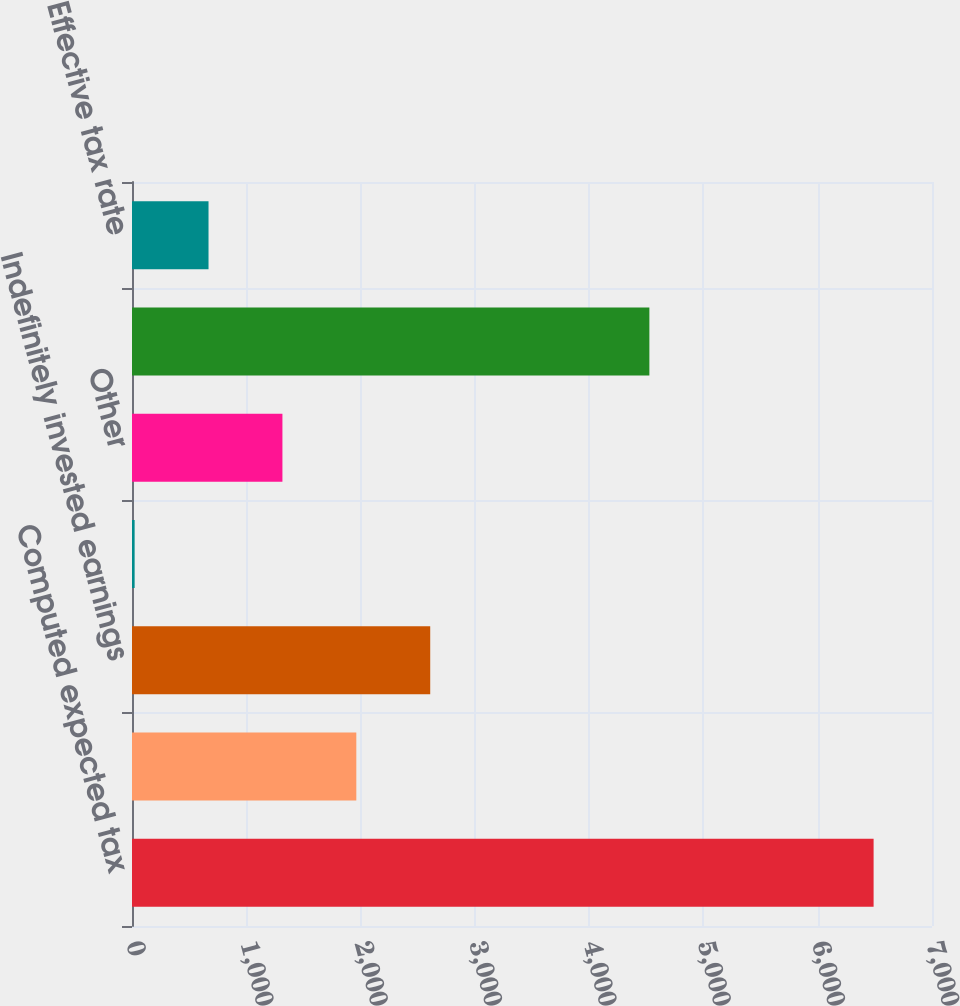Convert chart. <chart><loc_0><loc_0><loc_500><loc_500><bar_chart><fcel>Computed expected tax<fcel>State taxes net of federal<fcel>Indefinitely invested earnings<fcel>Research and development<fcel>Other<fcel>Provision for income taxes<fcel>Effective tax rate<nl><fcel>6489<fcel>1962.8<fcel>2609.4<fcel>23<fcel>1316.2<fcel>4527<fcel>669.6<nl></chart> 